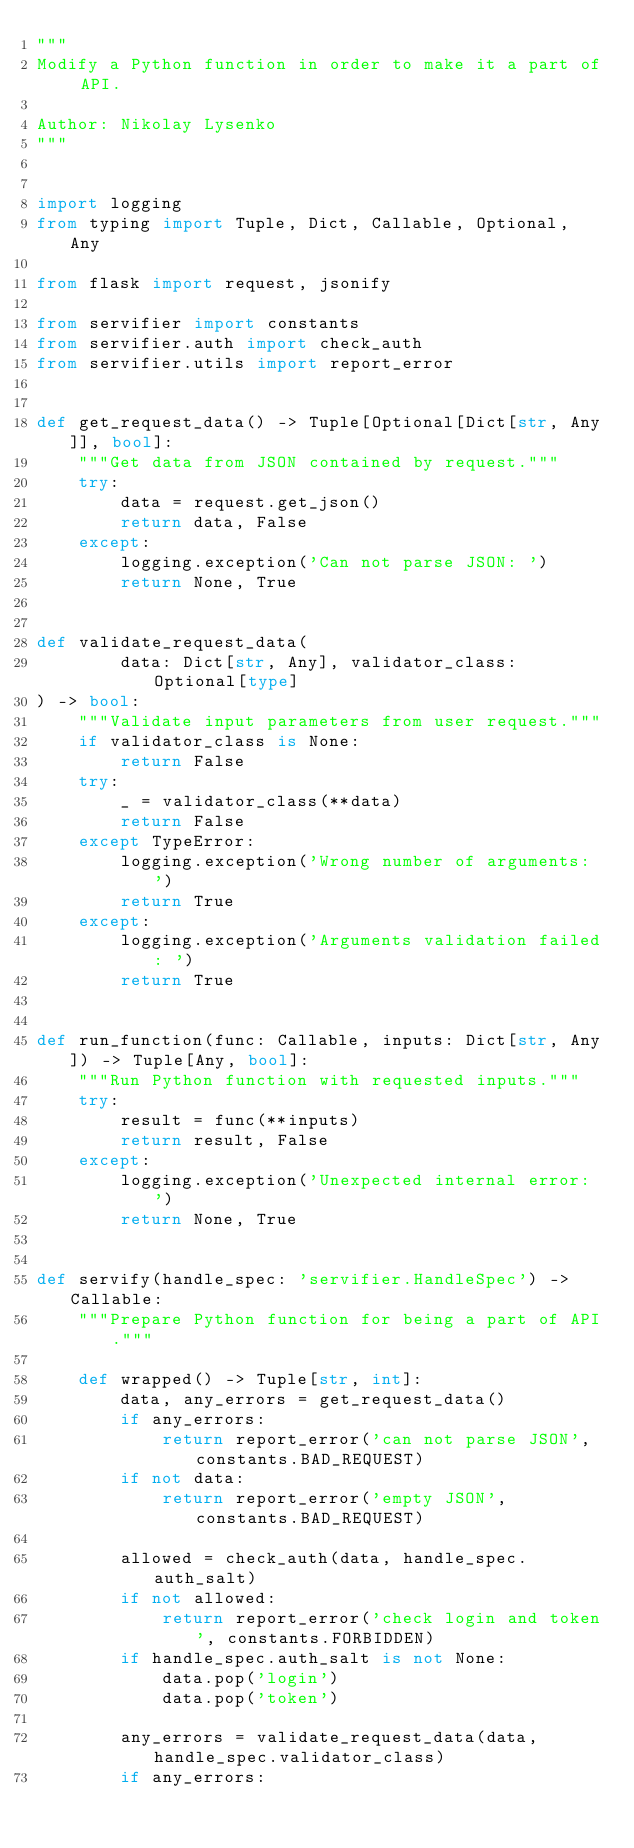Convert code to text. <code><loc_0><loc_0><loc_500><loc_500><_Python_>"""
Modify a Python function in order to make it a part of API.

Author: Nikolay Lysenko
"""


import logging
from typing import Tuple, Dict, Callable, Optional, Any

from flask import request, jsonify

from servifier import constants
from servifier.auth import check_auth
from servifier.utils import report_error


def get_request_data() -> Tuple[Optional[Dict[str, Any]], bool]:
    """Get data from JSON contained by request."""
    try:
        data = request.get_json()
        return data, False
    except:
        logging.exception('Can not parse JSON: ')
        return None, True


def validate_request_data(
        data: Dict[str, Any], validator_class: Optional[type]
) -> bool:
    """Validate input parameters from user request."""
    if validator_class is None:
        return False
    try:
        _ = validator_class(**data)
        return False
    except TypeError:
        logging.exception('Wrong number of arguments: ')
        return True
    except:
        logging.exception('Arguments validation failed: ')
        return True


def run_function(func: Callable, inputs: Dict[str, Any]) -> Tuple[Any, bool]:
    """Run Python function with requested inputs."""
    try:
        result = func(**inputs)
        return result, False
    except:
        logging.exception('Unexpected internal error: ')
        return None, True


def servify(handle_spec: 'servifier.HandleSpec') -> Callable:
    """Prepare Python function for being a part of API."""

    def wrapped() -> Tuple[str, int]:
        data, any_errors = get_request_data()
        if any_errors:
            return report_error('can not parse JSON', constants.BAD_REQUEST)
        if not data:
            return report_error('empty JSON', constants.BAD_REQUEST)

        allowed = check_auth(data, handle_spec.auth_salt)
        if not allowed:
            return report_error('check login and token', constants.FORBIDDEN)
        if handle_spec.auth_salt is not None:
            data.pop('login')
            data.pop('token')

        any_errors = validate_request_data(data, handle_spec.validator_class)
        if any_errors:</code> 